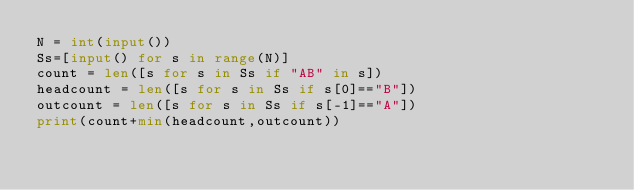<code> <loc_0><loc_0><loc_500><loc_500><_Python_>N = int(input())
Ss=[input() for s in range(N)]
count = len([s for s in Ss if "AB" in s])
headcount = len([s for s in Ss if s[0]=="B"])
outcount = len([s for s in Ss if s[-1]=="A"])
print(count+min(headcount,outcount))</code> 